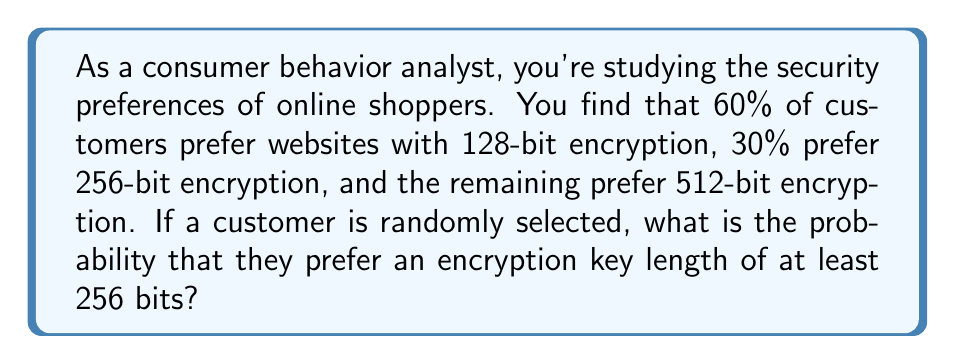Provide a solution to this math problem. Let's approach this step-by-step:

1) First, let's define our events:
   Let A be the event that a customer prefers 128-bit encryption
   Let B be the event that a customer prefers 256-bit encryption
   Let C be the event that a customer prefers 512-bit encryption

2) We're given the following probabilities:
   P(A) = 60% = 0.60
   P(B) = 30% = 0.30
   P(C) = 1 - P(A) - P(B) = 1 - 0.60 - 0.30 = 0.10

3) We want to find the probability of a customer preferring at least 256-bit encryption. This includes both 256-bit and 512-bit preferences.

4) We can express this as:
   P(at least 256-bit) = P(B or C)

5) Since B and C are mutually exclusive events (a customer can't prefer both simultaneously), we can add their probabilities:

   P(B or C) = P(B) + P(C)

6) Substituting the values:
   P(B or C) = 0.30 + 0.10 = 0.40

7) Therefore, the probability is 0.40 or 40%.
Answer: $0.40$ 